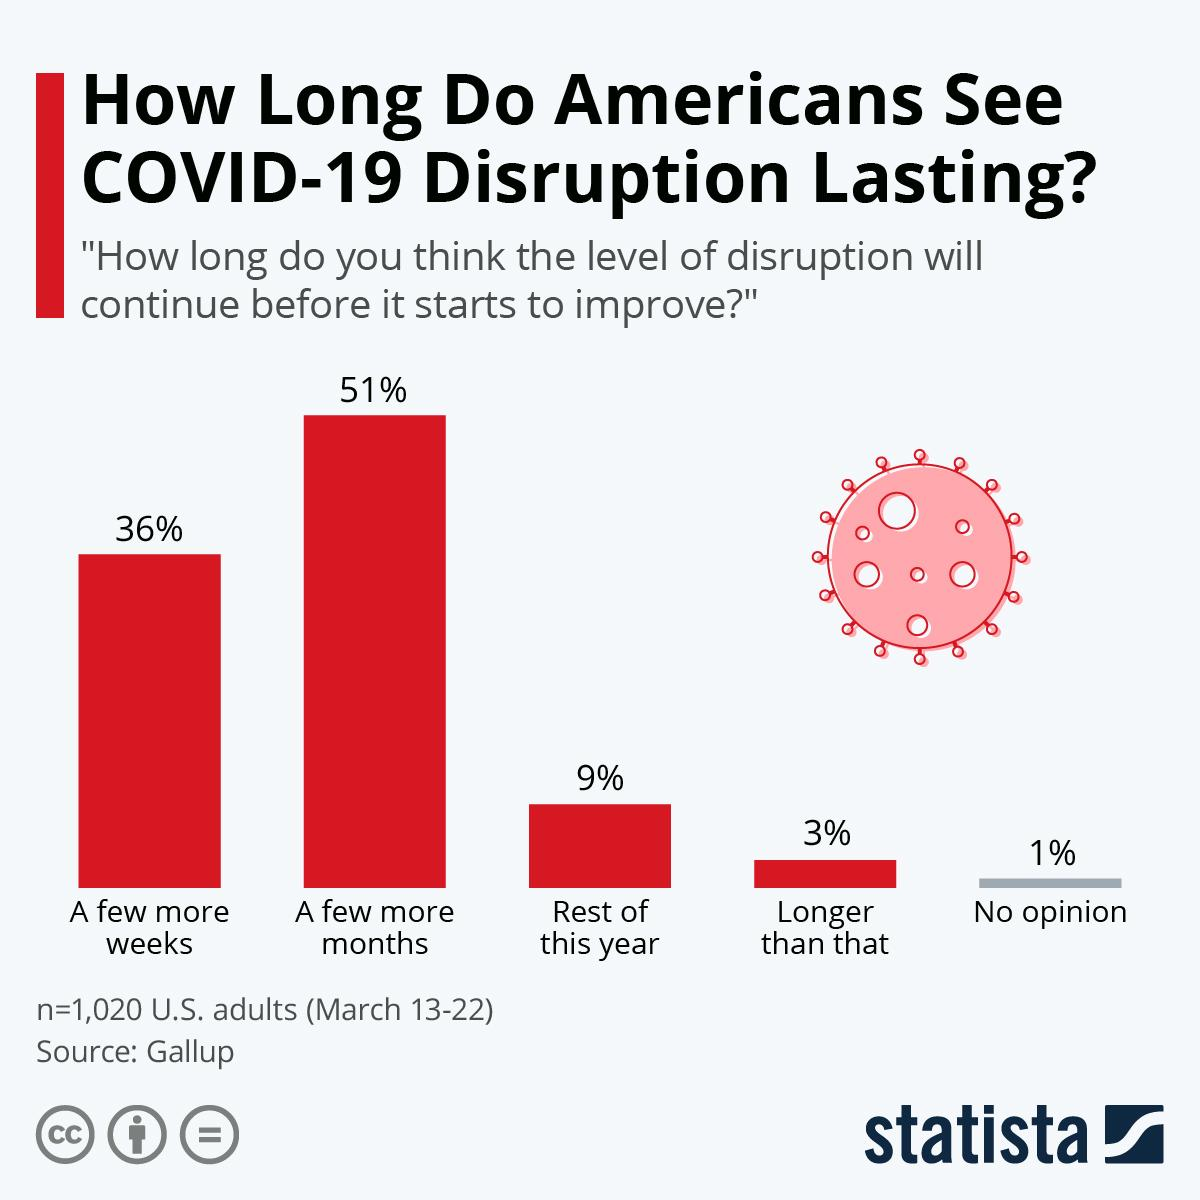Outline some significant characteristics in this image. The opinion that received the second highest number of votes is... Out of the people who voted, 91.8% voted for the opinion that the decision should be made by the end of this year. The inverse of the percentage of people who have "No Opinion" is approximately 99%. The opinion that received the third highest number of votes for the duration of the COVID-19 pandemic is "Which is the opinion which has third highest no of votes for duration of corona? Rest of this year.. The percentage difference in first and second opinions is 15%. 